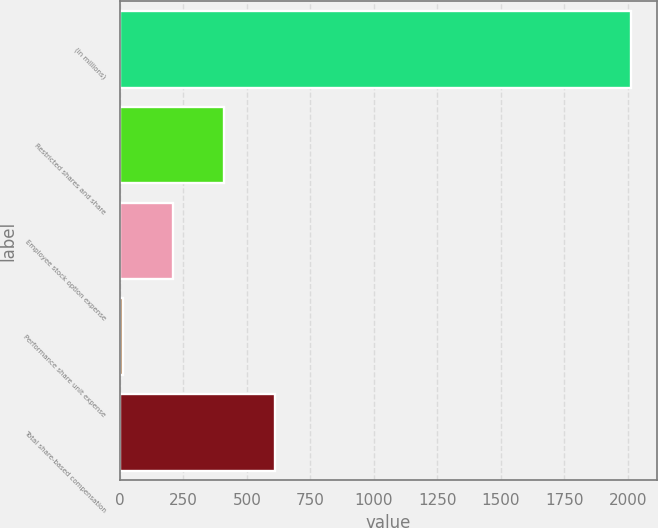<chart> <loc_0><loc_0><loc_500><loc_500><bar_chart><fcel>(in millions)<fcel>Restricted shares and share<fcel>Employee stock option expense<fcel>Performance share unit expense<fcel>Total share-based compensation<nl><fcel>2013<fcel>410.6<fcel>210.3<fcel>10<fcel>610.9<nl></chart> 